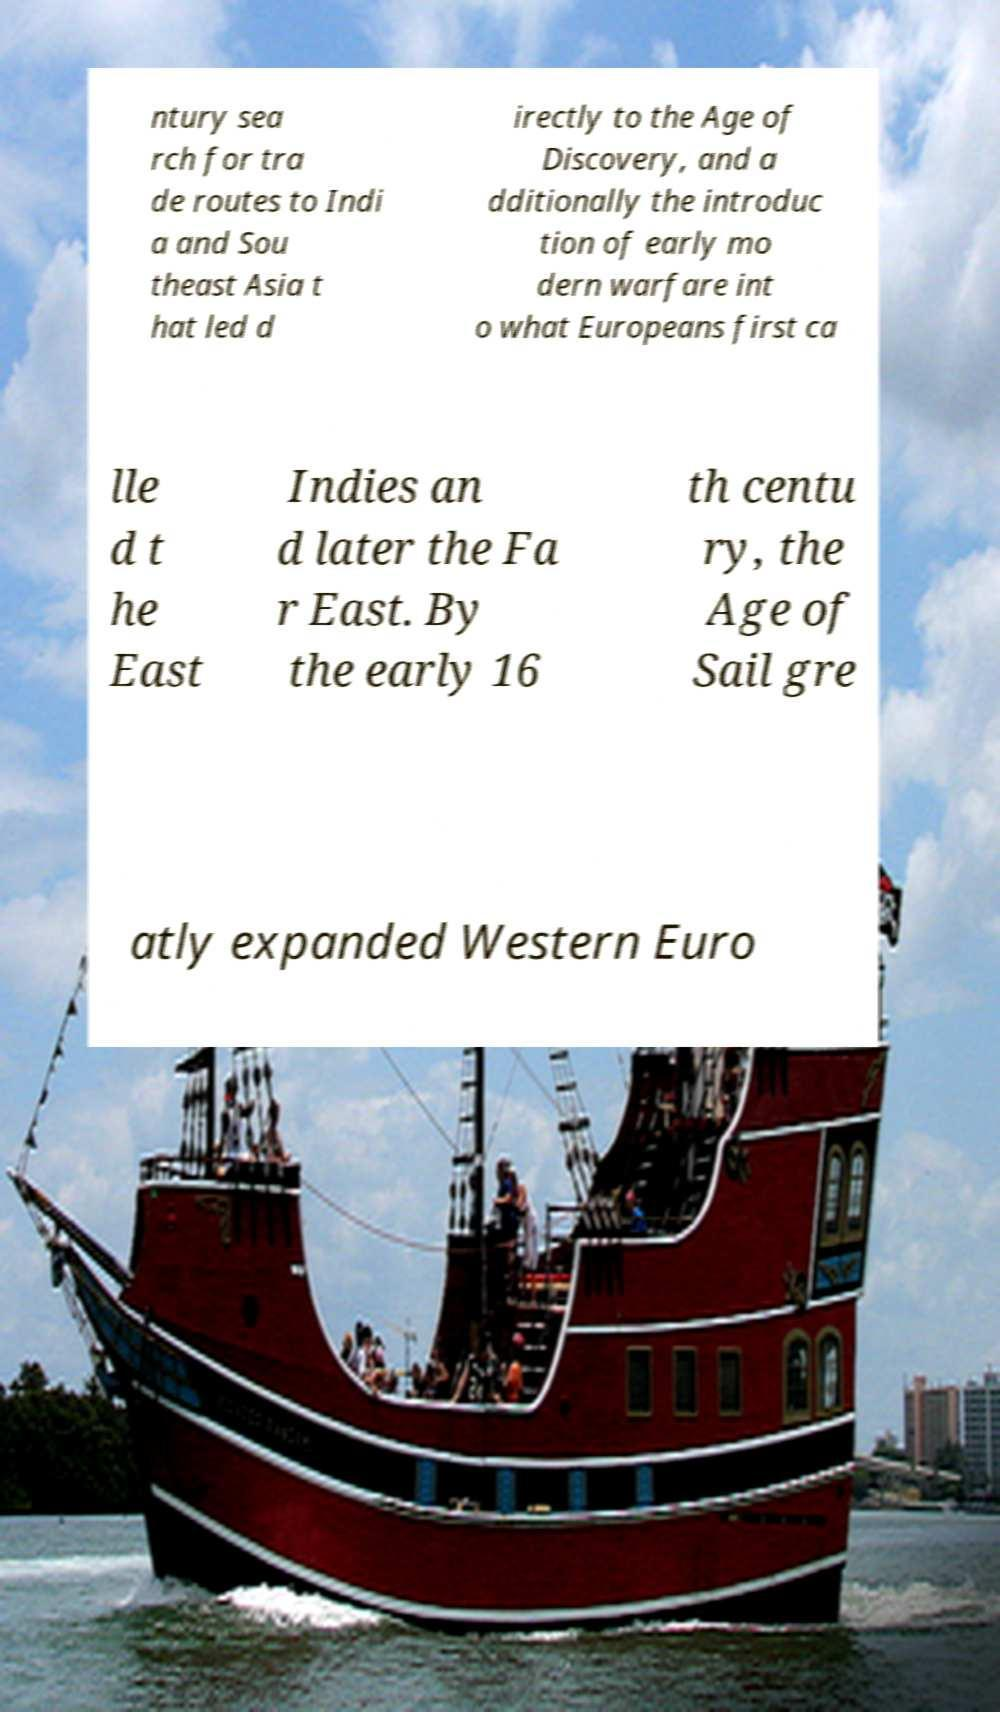Can you read and provide the text displayed in the image?This photo seems to have some interesting text. Can you extract and type it out for me? ntury sea rch for tra de routes to Indi a and Sou theast Asia t hat led d irectly to the Age of Discovery, and a dditionally the introduc tion of early mo dern warfare int o what Europeans first ca lle d t he East Indies an d later the Fa r East. By the early 16 th centu ry, the Age of Sail gre atly expanded Western Euro 